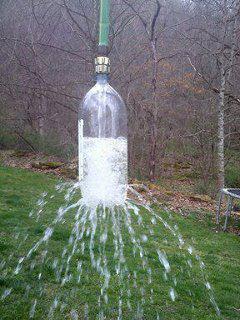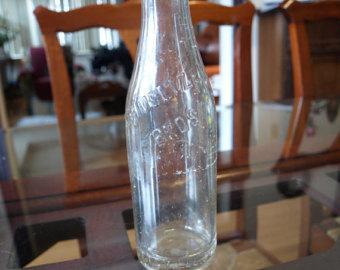The first image is the image on the left, the second image is the image on the right. Evaluate the accuracy of this statement regarding the images: "There are three glass bottles in the left image.". Is it true? Answer yes or no. No. The first image is the image on the left, the second image is the image on the right. For the images shown, is this caption "There are at most 3 bottles in the image pair." true? Answer yes or no. Yes. 